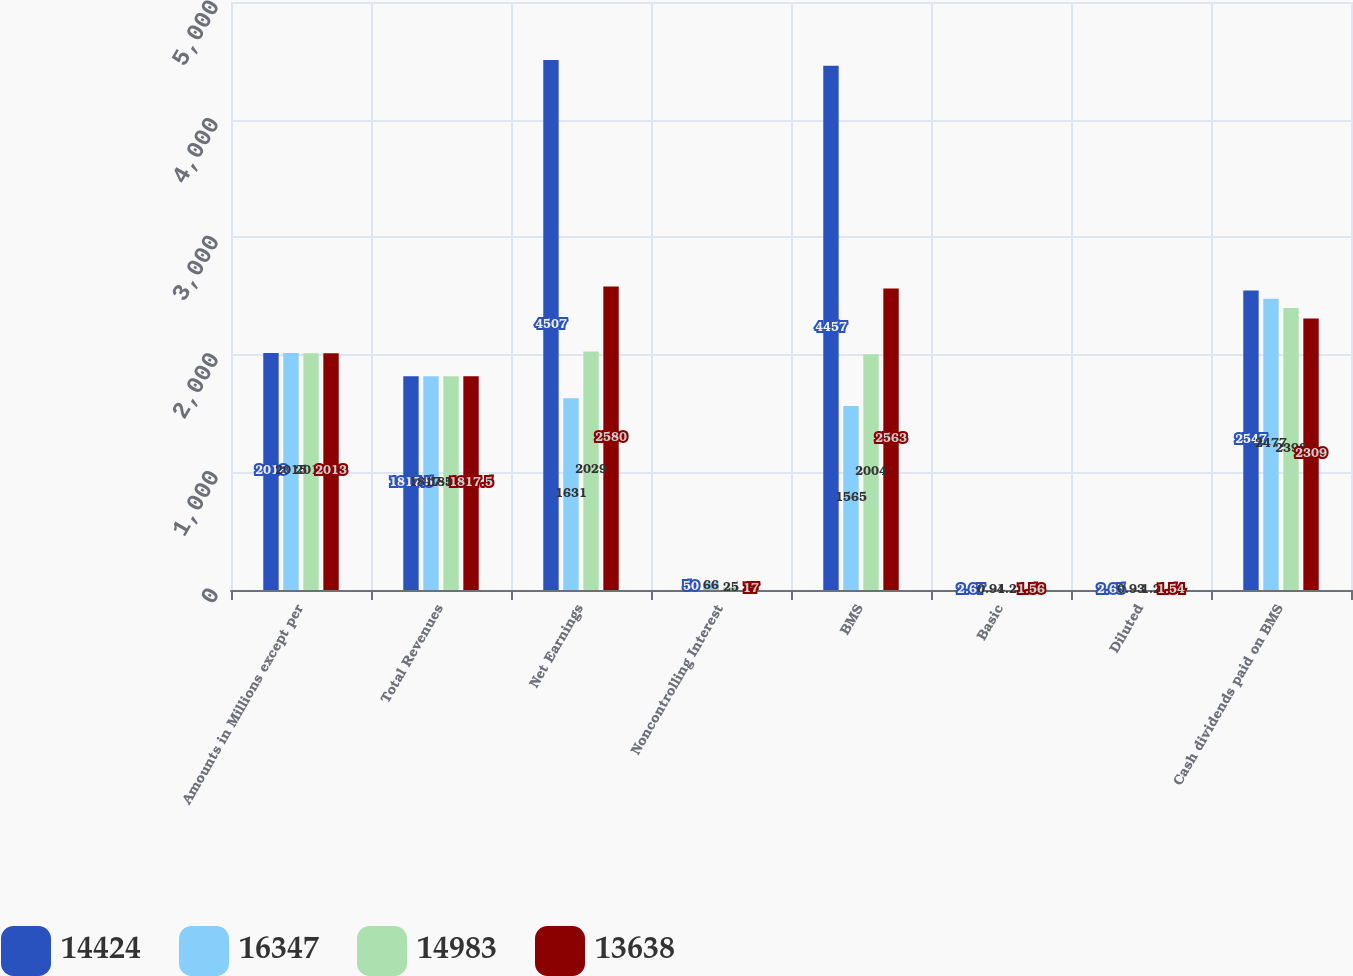Convert chart to OTSL. <chart><loc_0><loc_0><loc_500><loc_500><stacked_bar_chart><ecel><fcel>Amounts in Millions except per<fcel>Total Revenues<fcel>Net Earnings<fcel>Noncontrolling Interest<fcel>BMS<fcel>Basic<fcel>Diluted<fcel>Cash dividends paid on BMS<nl><fcel>14424<fcel>2016<fcel>1817.5<fcel>4507<fcel>50<fcel>4457<fcel>2.67<fcel>2.65<fcel>2547<nl><fcel>16347<fcel>2015<fcel>1817.5<fcel>1631<fcel>66<fcel>1565<fcel>0.94<fcel>0.93<fcel>2477<nl><fcel>14983<fcel>2014<fcel>1817.5<fcel>2029<fcel>25<fcel>2004<fcel>1.21<fcel>1.2<fcel>2398<nl><fcel>13638<fcel>2013<fcel>1817.5<fcel>2580<fcel>17<fcel>2563<fcel>1.56<fcel>1.54<fcel>2309<nl></chart> 